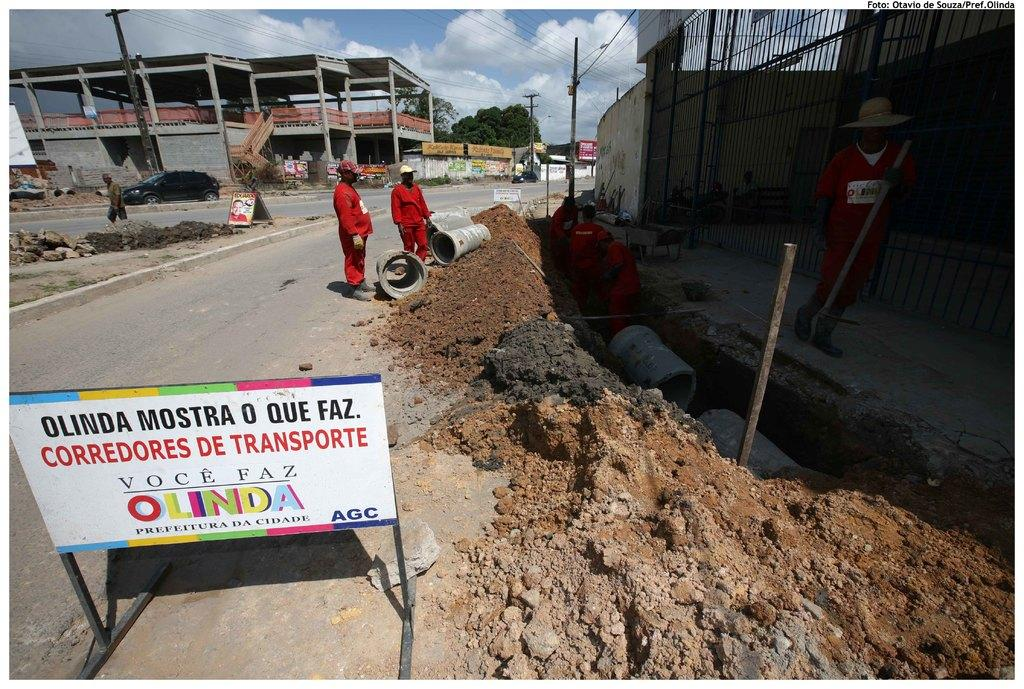Where are the persons located in the image? The persons are in the right corner of the image. What can be seen in the background of the image? There are buildings and trees in the background of the image. What type of fruit is hanging from the trees in the image? There is no fruit visible in the image; only buildings and trees can be seen in the background. 